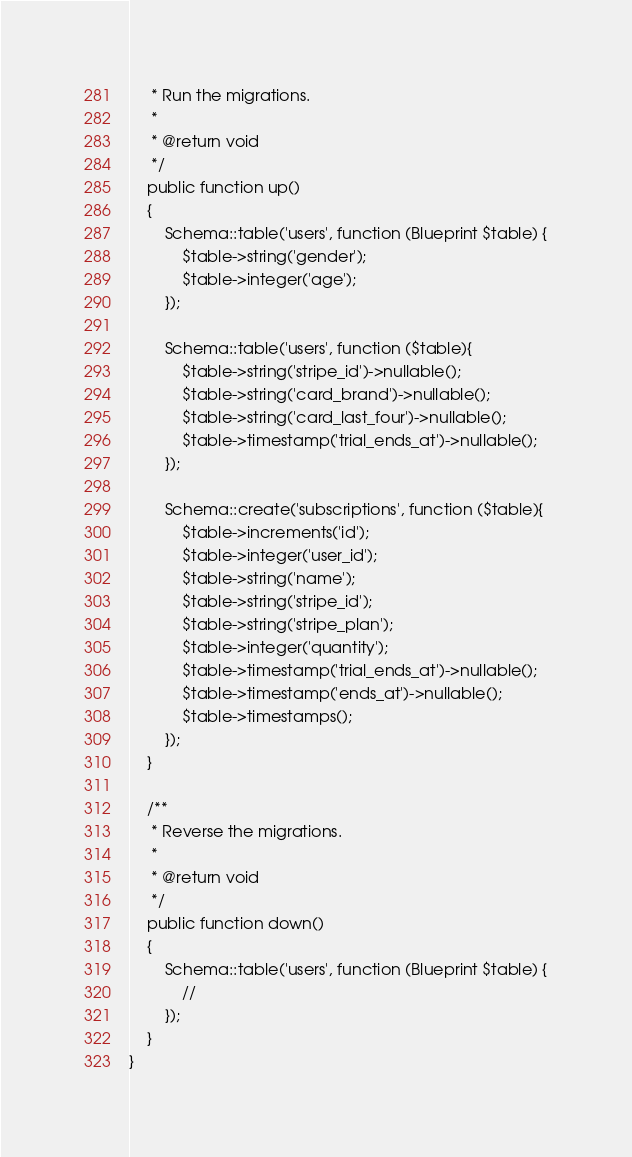Convert code to text. <code><loc_0><loc_0><loc_500><loc_500><_PHP_>     * Run the migrations.
     *
     * @return void
     */
    public function up()
    {
        Schema::table('users', function (Blueprint $table) {
            $table->string('gender');
            $table->integer('age');
        });

        Schema::table('users', function ($table){
            $table->string('stripe_id')->nullable();
            $table->string('card_brand')->nullable();
            $table->string('card_last_four')->nullable();
            $table->timestamp('trial_ends_at')->nullable();
        });

        Schema::create('subscriptions', function ($table){
            $table->increments('id');
            $table->integer('user_id');
            $table->string('name');
            $table->string('stripe_id');
            $table->string('stripe_plan');
            $table->integer('quantity');
            $table->timestamp('trial_ends_at')->nullable();
            $table->timestamp('ends_at')->nullable();
            $table->timestamps();
        });
    }

    /**
     * Reverse the migrations.
     *
     * @return void
     */
    public function down()
    {
        Schema::table('users', function (Blueprint $table) {
            //
        });
    }
}
</code> 